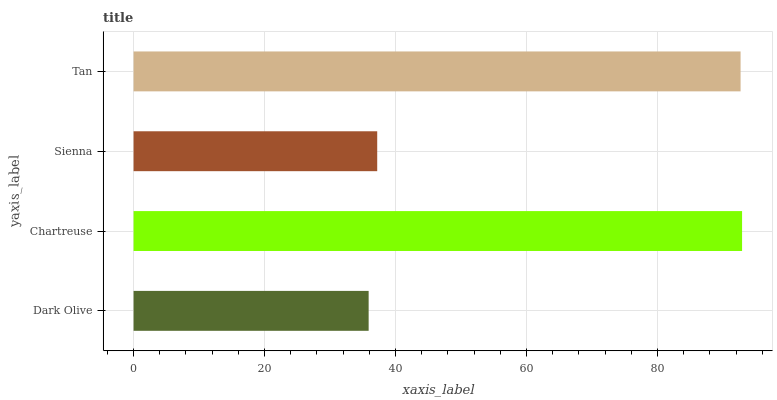Is Dark Olive the minimum?
Answer yes or no. Yes. Is Chartreuse the maximum?
Answer yes or no. Yes. Is Sienna the minimum?
Answer yes or no. No. Is Sienna the maximum?
Answer yes or no. No. Is Chartreuse greater than Sienna?
Answer yes or no. Yes. Is Sienna less than Chartreuse?
Answer yes or no. Yes. Is Sienna greater than Chartreuse?
Answer yes or no. No. Is Chartreuse less than Sienna?
Answer yes or no. No. Is Tan the high median?
Answer yes or no. Yes. Is Sienna the low median?
Answer yes or no. Yes. Is Dark Olive the high median?
Answer yes or no. No. Is Tan the low median?
Answer yes or no. No. 